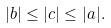<formula> <loc_0><loc_0><loc_500><loc_500>| b | \leq | c | \leq | a | .</formula> 